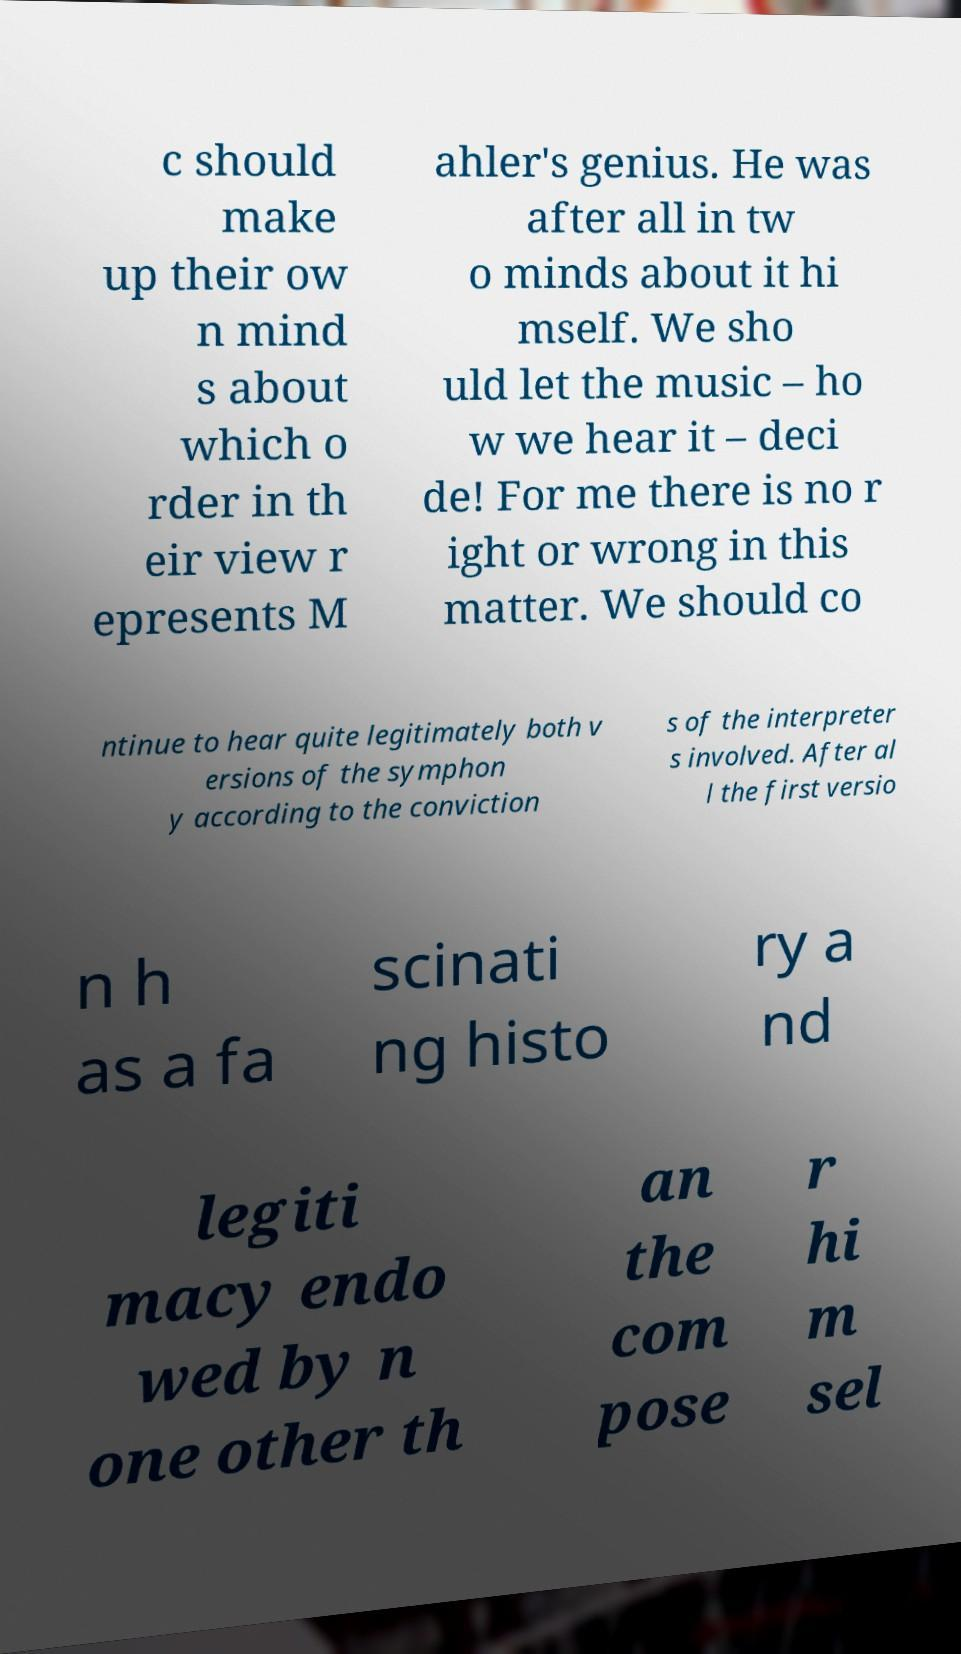I need the written content from this picture converted into text. Can you do that? c should make up their ow n mind s about which o rder in th eir view r epresents M ahler's genius. He was after all in tw o minds about it hi mself. We sho uld let the music – ho w we hear it – deci de! For me there is no r ight or wrong in this matter. We should co ntinue to hear quite legitimately both v ersions of the symphon y according to the conviction s of the interpreter s involved. After al l the first versio n h as a fa scinati ng histo ry a nd legiti macy endo wed by n one other th an the com pose r hi m sel 